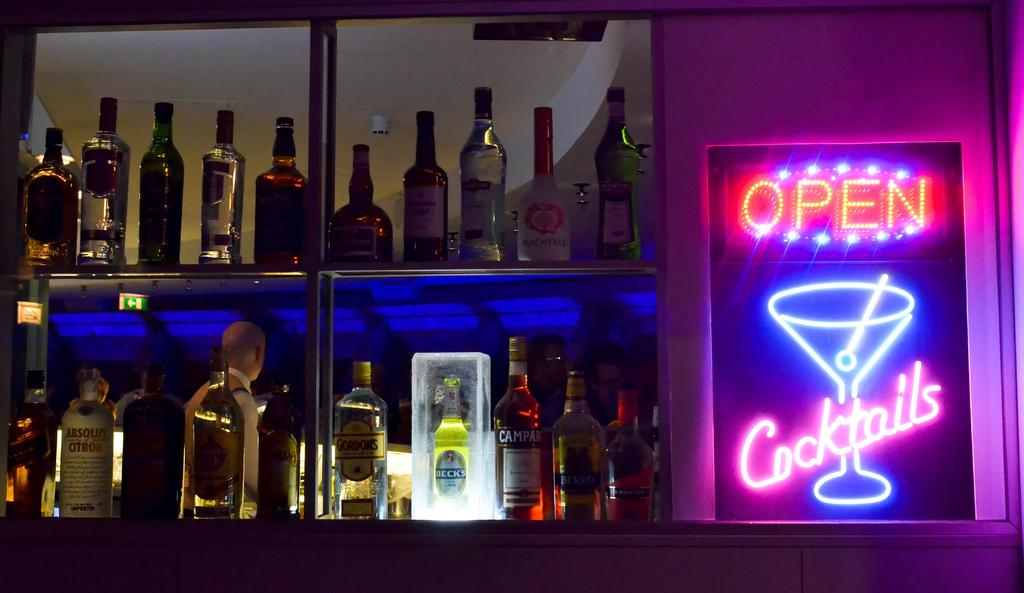<image>
Render a clear and concise summary of the photo. A shelf full of different alcohol bottles and neon sign that has open on it. 